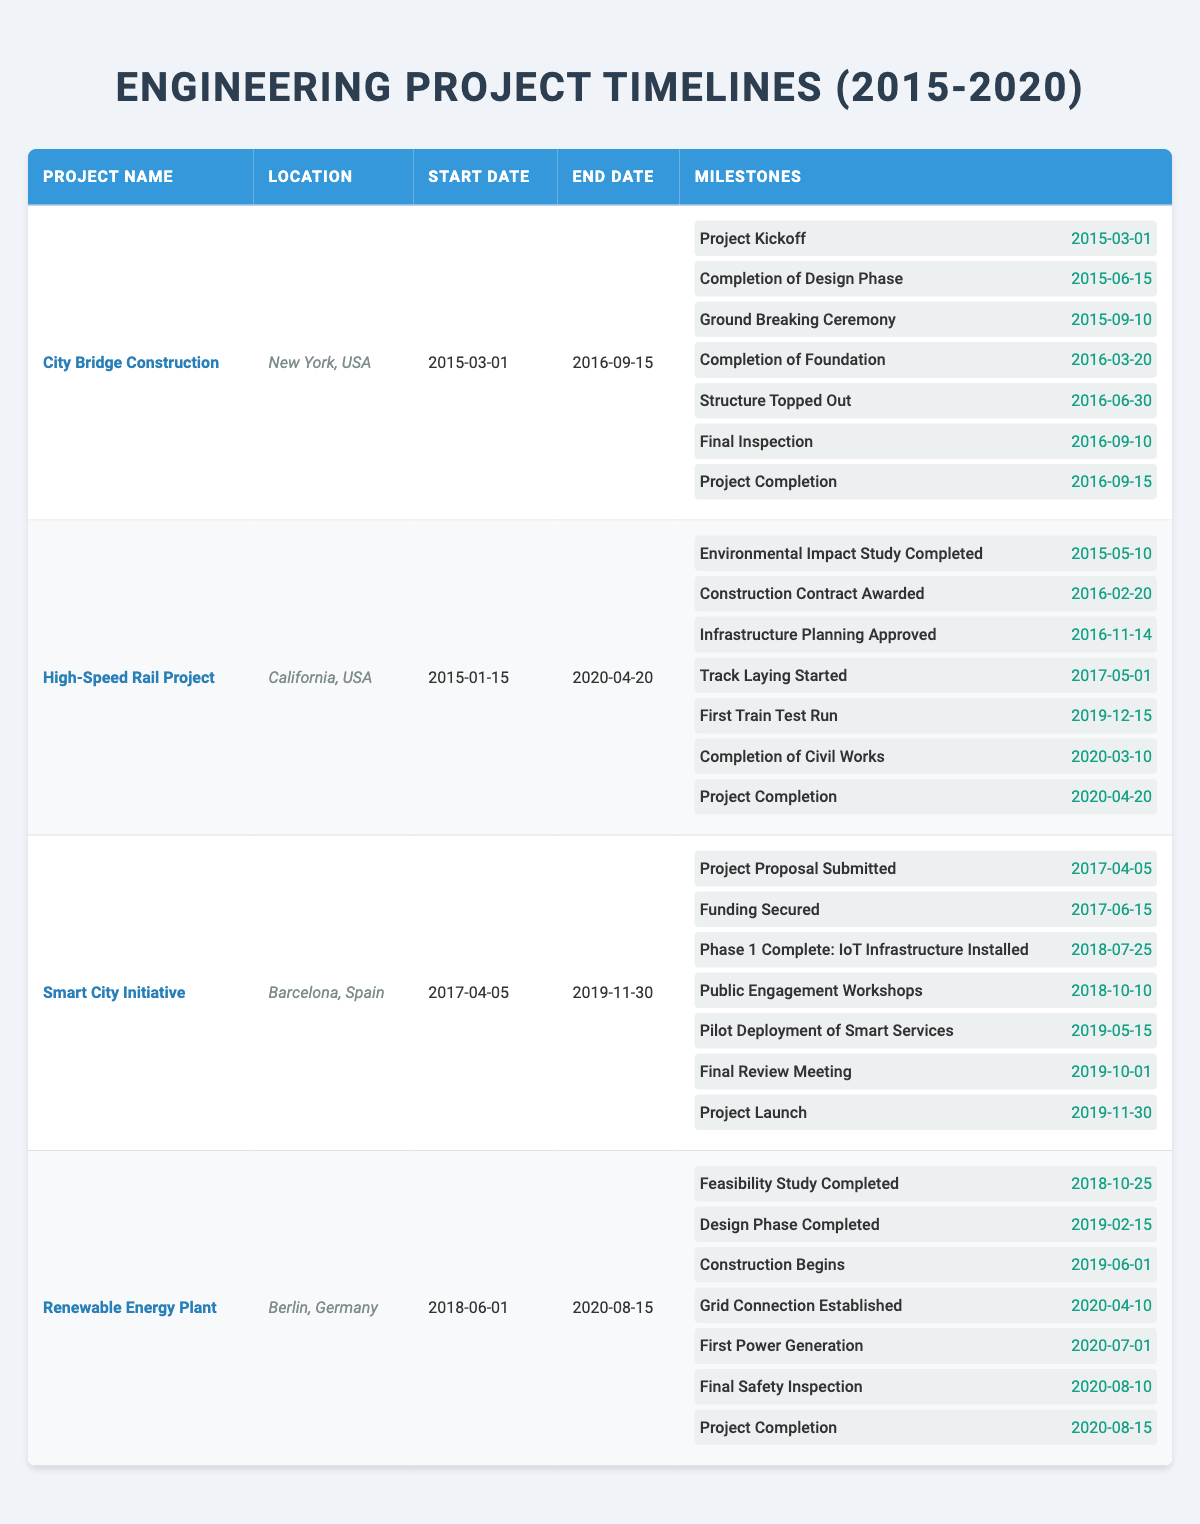What is the location of the "Renewable Energy Plant"? The table shows the location column, and for the "Renewable Energy Plant," it lists "Berlin, Germany" as its location.
Answer: Berlin, Germany When did the "City Bridge Construction" project start? By looking at the "Start Date" column in the table, the "City Bridge Construction" project started on "2015-03-01".
Answer: 2015-03-01 What is the end date of the "High-Speed Rail Project"? The end date for the "High-Speed Rail Project" is found in the "End Date" column, where it states "2020-04-20".
Answer: 2020-04-20 Which project had its "Completion of Design Phase" milestone on June 15, 2015? Checking the milestones of each project, the "Completion of Design Phase" occurred on June 15, 2015, for the "City Bridge Construction" project.
Answer: City Bridge Construction How many milestones were achieved by the "Smart City Initiative" by October 2019? The "Smart City Initiative" has seven milestones listed, and as of the "Final Review Meeting" on October 1, 2019, all prior milestones were completed, totaling six milestones.
Answer: 6 Does the "High-Speed Rail Project" have a milestone for "Track Laying Started"? The "High-Speed Rail Project" contains a milestone named "Track Laying Started," which occurred on "2017-05-01", confirming the information to be true.
Answer: Yes Which project had the latest completion date? The latest completion date can be identified by comparing the end dates of all projects. The "Renewable Energy Plant" has the completion date of "2020-08-15," which is the latest among all listed.
Answer: Renewable Energy Plant What is the total duration of the "Smart City Initiative" project? The duration can be calculated from the "Start Date" (2017-04-05) to the "End Date" (2019-11-30). Counting months between these dates, the project lasted 2 years and 7 months.
Answer: 2 years and 7 months How many projects started in 2015? By reviewing the start dates listed in the table, both "City Bridge Construction" and "High-Speed Rail Project" started in 2015, totaling two projects.
Answer: 2 Did the "Renewable Energy Plant" have a milestone for "First Power Generation"? The "Renewable Energy Plant" includes a milestone for "First Power Generation" that occurred on "2020-07-01," confirming the inclusion of this milestone.
Answer: Yes Which milestone occurred first in the "High-Speed Rail Project"? The first milestone is the "Environmental Impact Study Completed" on "2015-05-10," as per the order in the table, making it the earliest milestone in that project.
Answer: Environmental Impact Study Completed 